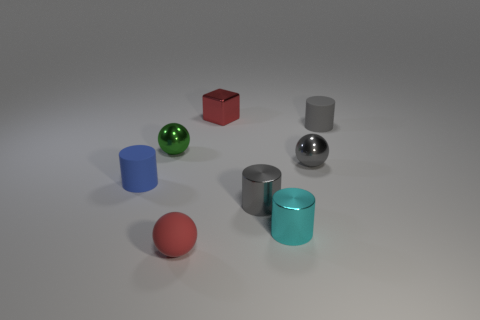Do the tiny gray matte object and the small cyan thing have the same shape?
Provide a short and direct response. Yes. There is a ball that is made of the same material as the green thing; what size is it?
Provide a succinct answer. Small. Is the color of the rubber sphere the same as the metal cube?
Give a very brief answer. Yes. What number of matte balls are behind the small rubber thing that is on the right side of the gray cylinder in front of the small blue object?
Provide a short and direct response. 0. There is a rubber thing that is to the right of the red object that is right of the red matte sphere; what is its shape?
Make the answer very short. Cylinder. What color is the small metallic ball that is right of the tiny cyan metallic object?
Offer a terse response. Gray. What is the material of the ball that is on the right side of the tiny metal object behind the small matte cylinder that is on the right side of the small red shiny object?
Ensure brevity in your answer.  Metal. The other tiny matte object that is the same shape as the green thing is what color?
Provide a short and direct response. Red. What number of metallic blocks have the same color as the tiny rubber sphere?
Your answer should be very brief. 1. Is the gray rubber object the same size as the red block?
Your response must be concise. Yes. 